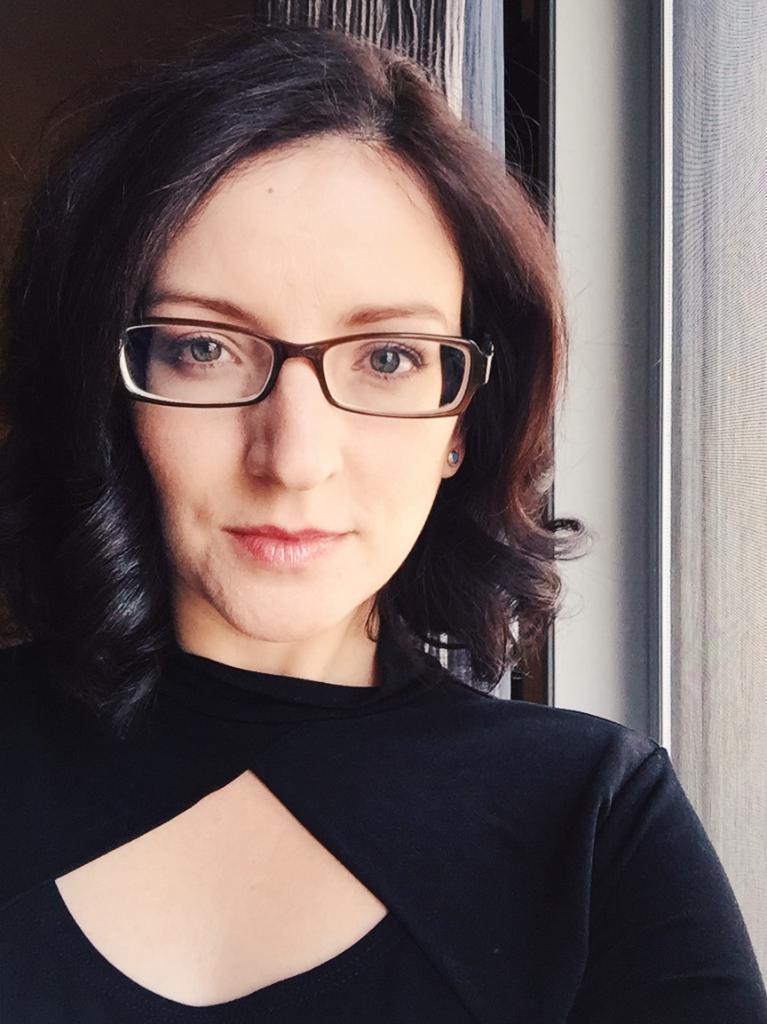In one or two sentences, can you explain what this image depicts? In the image a woman is standing and smiling. Behind her there is curtain and wall. 